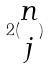Convert formula to latex. <formula><loc_0><loc_0><loc_500><loc_500>2 ( \begin{matrix} n \\ j \end{matrix} )</formula> 